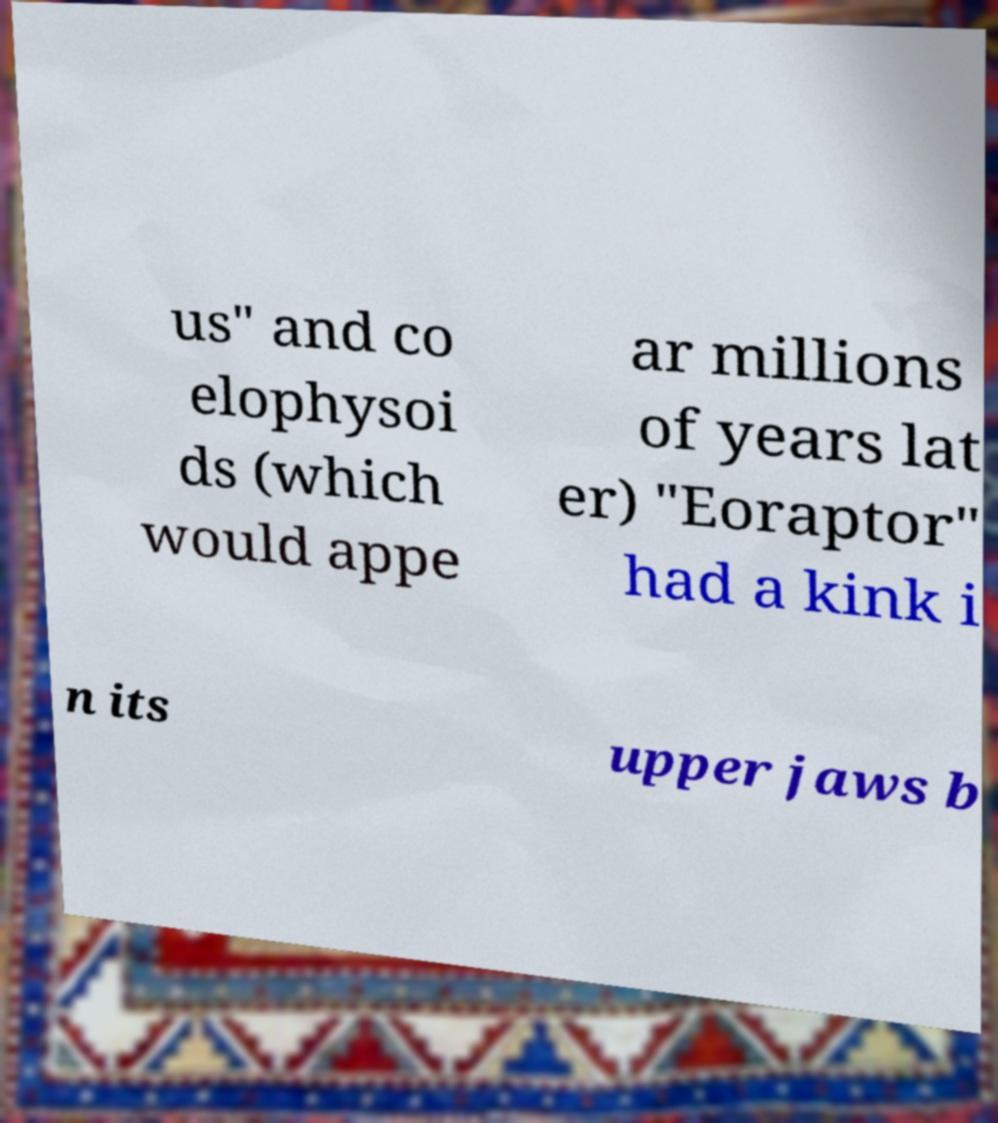Can you accurately transcribe the text from the provided image for me? us" and co elophysoi ds (which would appe ar millions of years lat er) "Eoraptor" had a kink i n its upper jaws b 